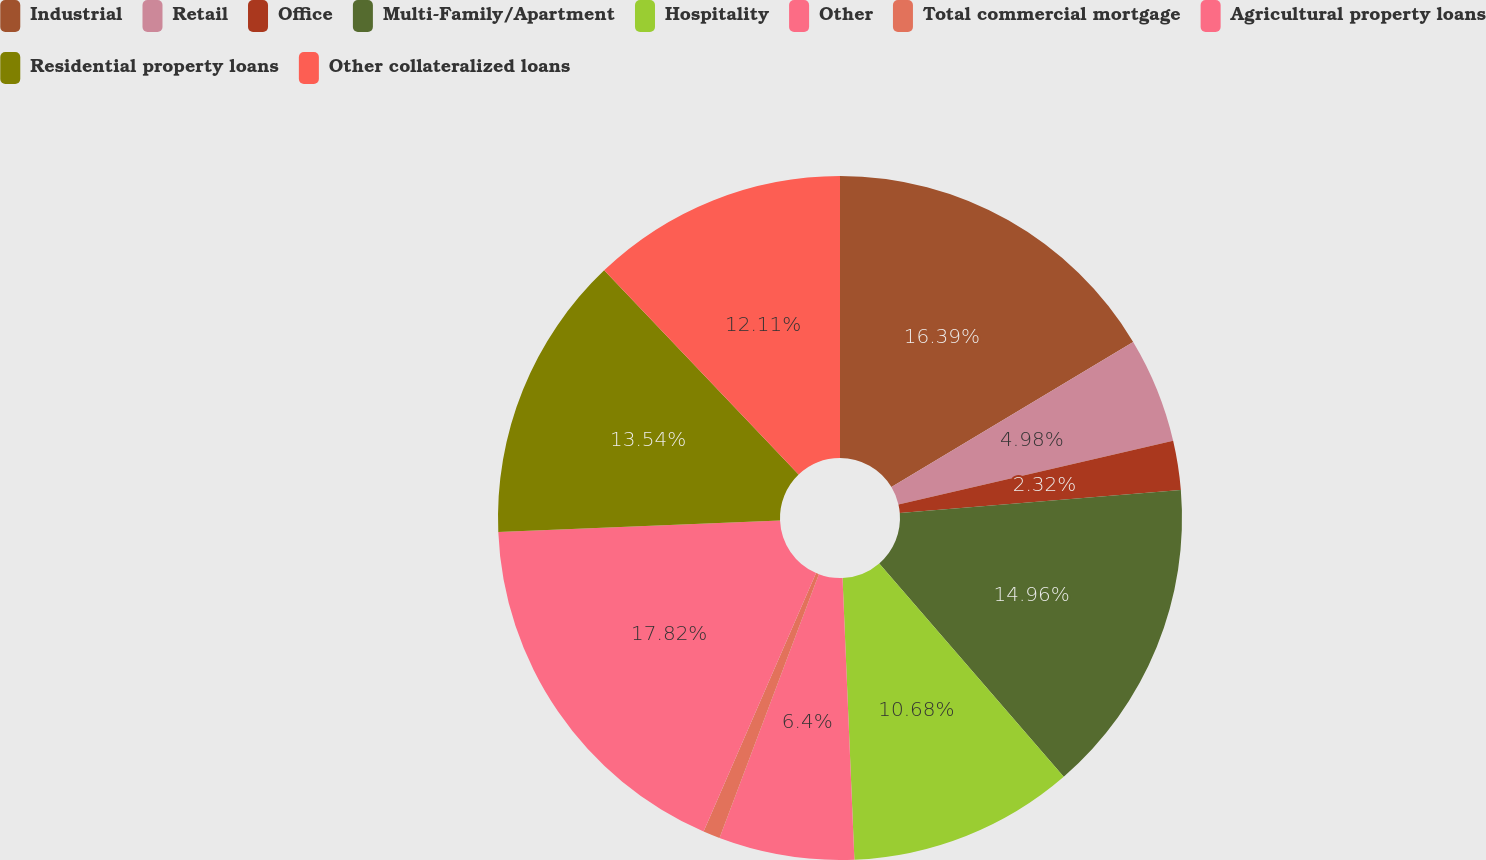Convert chart to OTSL. <chart><loc_0><loc_0><loc_500><loc_500><pie_chart><fcel>Industrial<fcel>Retail<fcel>Office<fcel>Multi-Family/Apartment<fcel>Hospitality<fcel>Other<fcel>Total commercial mortgage<fcel>Agricultural property loans<fcel>Residential property loans<fcel>Other collateralized loans<nl><fcel>16.39%<fcel>4.98%<fcel>2.32%<fcel>14.96%<fcel>10.68%<fcel>6.4%<fcel>0.8%<fcel>17.82%<fcel>13.54%<fcel>12.11%<nl></chart> 